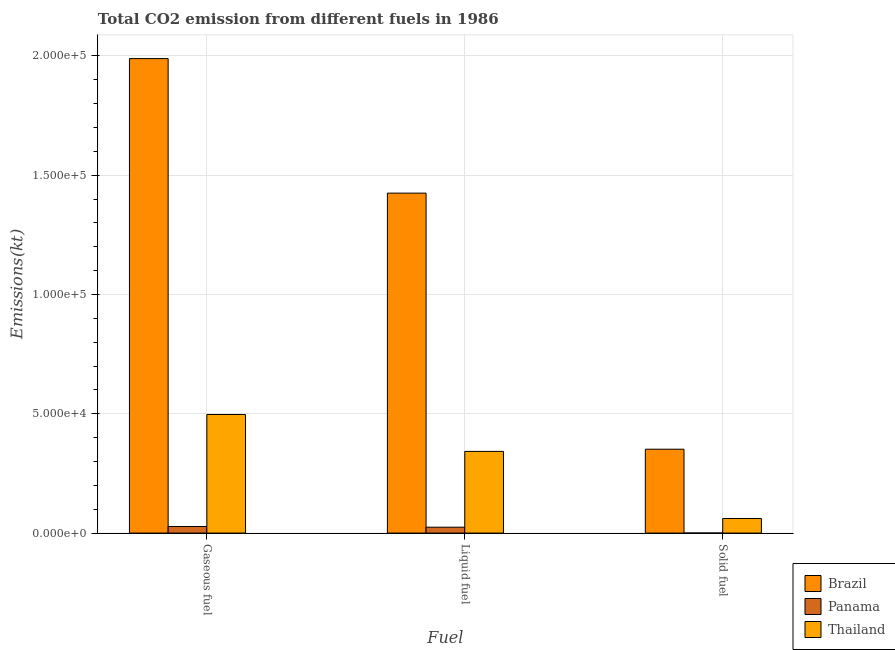How many different coloured bars are there?
Your answer should be compact. 3. How many groups of bars are there?
Your response must be concise. 3. Are the number of bars per tick equal to the number of legend labels?
Keep it short and to the point. Yes. How many bars are there on the 3rd tick from the left?
Offer a terse response. 3. What is the label of the 1st group of bars from the left?
Make the answer very short. Gaseous fuel. What is the amount of co2 emissions from gaseous fuel in Thailand?
Give a very brief answer. 4.97e+04. Across all countries, what is the maximum amount of co2 emissions from gaseous fuel?
Make the answer very short. 1.99e+05. Across all countries, what is the minimum amount of co2 emissions from solid fuel?
Ensure brevity in your answer.  22. In which country was the amount of co2 emissions from gaseous fuel minimum?
Offer a very short reply. Panama. What is the total amount of co2 emissions from liquid fuel in the graph?
Provide a short and direct response. 1.79e+05. What is the difference between the amount of co2 emissions from liquid fuel in Brazil and that in Panama?
Offer a terse response. 1.40e+05. What is the difference between the amount of co2 emissions from gaseous fuel in Thailand and the amount of co2 emissions from liquid fuel in Panama?
Offer a terse response. 4.72e+04. What is the average amount of co2 emissions from solid fuel per country?
Offer a terse response. 1.38e+04. What is the difference between the amount of co2 emissions from liquid fuel and amount of co2 emissions from gaseous fuel in Panama?
Offer a very short reply. -289.69. What is the ratio of the amount of co2 emissions from liquid fuel in Panama to that in Brazil?
Provide a short and direct response. 0.02. What is the difference between the highest and the second highest amount of co2 emissions from gaseous fuel?
Provide a succinct answer. 1.49e+05. What is the difference between the highest and the lowest amount of co2 emissions from gaseous fuel?
Give a very brief answer. 1.96e+05. Is the sum of the amount of co2 emissions from liquid fuel in Thailand and Brazil greater than the maximum amount of co2 emissions from gaseous fuel across all countries?
Give a very brief answer. No. What does the 2nd bar from the left in Solid fuel represents?
Give a very brief answer. Panama. What does the 3rd bar from the right in Gaseous fuel represents?
Provide a short and direct response. Brazil. Is it the case that in every country, the sum of the amount of co2 emissions from gaseous fuel and amount of co2 emissions from liquid fuel is greater than the amount of co2 emissions from solid fuel?
Offer a very short reply. Yes. Are all the bars in the graph horizontal?
Make the answer very short. No. How many countries are there in the graph?
Your answer should be very brief. 3. Are the values on the major ticks of Y-axis written in scientific E-notation?
Keep it short and to the point. Yes. Does the graph contain any zero values?
Offer a very short reply. No. How many legend labels are there?
Give a very brief answer. 3. What is the title of the graph?
Your answer should be compact. Total CO2 emission from different fuels in 1986. Does "Iraq" appear as one of the legend labels in the graph?
Provide a short and direct response. No. What is the label or title of the X-axis?
Offer a very short reply. Fuel. What is the label or title of the Y-axis?
Your response must be concise. Emissions(kt). What is the Emissions(kt) of Brazil in Gaseous fuel?
Provide a short and direct response. 1.99e+05. What is the Emissions(kt) in Panama in Gaseous fuel?
Give a very brief answer. 2753.92. What is the Emissions(kt) of Thailand in Gaseous fuel?
Keep it short and to the point. 4.97e+04. What is the Emissions(kt) of Brazil in Liquid fuel?
Provide a succinct answer. 1.42e+05. What is the Emissions(kt) in Panama in Liquid fuel?
Ensure brevity in your answer.  2464.22. What is the Emissions(kt) in Thailand in Liquid fuel?
Keep it short and to the point. 3.42e+04. What is the Emissions(kt) in Brazil in Solid fuel?
Give a very brief answer. 3.52e+04. What is the Emissions(kt) in Panama in Solid fuel?
Ensure brevity in your answer.  22. What is the Emissions(kt) in Thailand in Solid fuel?
Provide a succinct answer. 6112.89. Across all Fuel, what is the maximum Emissions(kt) of Brazil?
Keep it short and to the point. 1.99e+05. Across all Fuel, what is the maximum Emissions(kt) of Panama?
Your response must be concise. 2753.92. Across all Fuel, what is the maximum Emissions(kt) in Thailand?
Provide a succinct answer. 4.97e+04. Across all Fuel, what is the minimum Emissions(kt) of Brazil?
Offer a very short reply. 3.52e+04. Across all Fuel, what is the minimum Emissions(kt) of Panama?
Ensure brevity in your answer.  22. Across all Fuel, what is the minimum Emissions(kt) in Thailand?
Ensure brevity in your answer.  6112.89. What is the total Emissions(kt) in Brazil in the graph?
Your answer should be compact. 3.77e+05. What is the total Emissions(kt) in Panama in the graph?
Offer a very short reply. 5240.14. What is the total Emissions(kt) of Thailand in the graph?
Offer a terse response. 9.00e+04. What is the difference between the Emissions(kt) in Brazil in Gaseous fuel and that in Liquid fuel?
Provide a short and direct response. 5.64e+04. What is the difference between the Emissions(kt) in Panama in Gaseous fuel and that in Liquid fuel?
Offer a very short reply. 289.69. What is the difference between the Emissions(kt) of Thailand in Gaseous fuel and that in Liquid fuel?
Your response must be concise. 1.55e+04. What is the difference between the Emissions(kt) of Brazil in Gaseous fuel and that in Solid fuel?
Offer a terse response. 1.64e+05. What is the difference between the Emissions(kt) in Panama in Gaseous fuel and that in Solid fuel?
Offer a very short reply. 2731.91. What is the difference between the Emissions(kt) of Thailand in Gaseous fuel and that in Solid fuel?
Give a very brief answer. 4.36e+04. What is the difference between the Emissions(kt) in Brazil in Liquid fuel and that in Solid fuel?
Offer a very short reply. 1.07e+05. What is the difference between the Emissions(kt) of Panama in Liquid fuel and that in Solid fuel?
Provide a short and direct response. 2442.22. What is the difference between the Emissions(kt) in Thailand in Liquid fuel and that in Solid fuel?
Offer a terse response. 2.81e+04. What is the difference between the Emissions(kt) in Brazil in Gaseous fuel and the Emissions(kt) in Panama in Liquid fuel?
Keep it short and to the point. 1.96e+05. What is the difference between the Emissions(kt) of Brazil in Gaseous fuel and the Emissions(kt) of Thailand in Liquid fuel?
Keep it short and to the point. 1.65e+05. What is the difference between the Emissions(kt) in Panama in Gaseous fuel and the Emissions(kt) in Thailand in Liquid fuel?
Provide a short and direct response. -3.15e+04. What is the difference between the Emissions(kt) in Brazil in Gaseous fuel and the Emissions(kt) in Panama in Solid fuel?
Provide a short and direct response. 1.99e+05. What is the difference between the Emissions(kt) in Brazil in Gaseous fuel and the Emissions(kt) in Thailand in Solid fuel?
Your answer should be compact. 1.93e+05. What is the difference between the Emissions(kt) of Panama in Gaseous fuel and the Emissions(kt) of Thailand in Solid fuel?
Your answer should be very brief. -3358.97. What is the difference between the Emissions(kt) of Brazil in Liquid fuel and the Emissions(kt) of Panama in Solid fuel?
Your response must be concise. 1.42e+05. What is the difference between the Emissions(kt) of Brazil in Liquid fuel and the Emissions(kt) of Thailand in Solid fuel?
Provide a short and direct response. 1.36e+05. What is the difference between the Emissions(kt) in Panama in Liquid fuel and the Emissions(kt) in Thailand in Solid fuel?
Provide a succinct answer. -3648.66. What is the average Emissions(kt) in Brazil per Fuel?
Your response must be concise. 1.26e+05. What is the average Emissions(kt) of Panama per Fuel?
Make the answer very short. 1746.71. What is the average Emissions(kt) in Thailand per Fuel?
Your answer should be very brief. 3.00e+04. What is the difference between the Emissions(kt) of Brazil and Emissions(kt) of Panama in Gaseous fuel?
Provide a short and direct response. 1.96e+05. What is the difference between the Emissions(kt) in Brazil and Emissions(kt) in Thailand in Gaseous fuel?
Offer a very short reply. 1.49e+05. What is the difference between the Emissions(kt) of Panama and Emissions(kt) of Thailand in Gaseous fuel?
Your answer should be compact. -4.69e+04. What is the difference between the Emissions(kt) of Brazil and Emissions(kt) of Panama in Liquid fuel?
Give a very brief answer. 1.40e+05. What is the difference between the Emissions(kt) in Brazil and Emissions(kt) in Thailand in Liquid fuel?
Offer a very short reply. 1.08e+05. What is the difference between the Emissions(kt) in Panama and Emissions(kt) in Thailand in Liquid fuel?
Provide a succinct answer. -3.18e+04. What is the difference between the Emissions(kt) of Brazil and Emissions(kt) of Panama in Solid fuel?
Keep it short and to the point. 3.51e+04. What is the difference between the Emissions(kt) in Brazil and Emissions(kt) in Thailand in Solid fuel?
Your answer should be very brief. 2.90e+04. What is the difference between the Emissions(kt) in Panama and Emissions(kt) in Thailand in Solid fuel?
Provide a short and direct response. -6090.89. What is the ratio of the Emissions(kt) in Brazil in Gaseous fuel to that in Liquid fuel?
Keep it short and to the point. 1.4. What is the ratio of the Emissions(kt) in Panama in Gaseous fuel to that in Liquid fuel?
Provide a short and direct response. 1.12. What is the ratio of the Emissions(kt) of Thailand in Gaseous fuel to that in Liquid fuel?
Your answer should be very brief. 1.45. What is the ratio of the Emissions(kt) in Brazil in Gaseous fuel to that in Solid fuel?
Keep it short and to the point. 5.66. What is the ratio of the Emissions(kt) in Panama in Gaseous fuel to that in Solid fuel?
Give a very brief answer. 125.17. What is the ratio of the Emissions(kt) of Thailand in Gaseous fuel to that in Solid fuel?
Provide a succinct answer. 8.13. What is the ratio of the Emissions(kt) in Brazil in Liquid fuel to that in Solid fuel?
Offer a very short reply. 4.05. What is the ratio of the Emissions(kt) of Panama in Liquid fuel to that in Solid fuel?
Keep it short and to the point. 112. What is the ratio of the Emissions(kt) in Thailand in Liquid fuel to that in Solid fuel?
Offer a very short reply. 5.6. What is the difference between the highest and the second highest Emissions(kt) of Brazil?
Give a very brief answer. 5.64e+04. What is the difference between the highest and the second highest Emissions(kt) of Panama?
Ensure brevity in your answer.  289.69. What is the difference between the highest and the second highest Emissions(kt) in Thailand?
Ensure brevity in your answer.  1.55e+04. What is the difference between the highest and the lowest Emissions(kt) of Brazil?
Ensure brevity in your answer.  1.64e+05. What is the difference between the highest and the lowest Emissions(kt) of Panama?
Offer a terse response. 2731.91. What is the difference between the highest and the lowest Emissions(kt) in Thailand?
Give a very brief answer. 4.36e+04. 